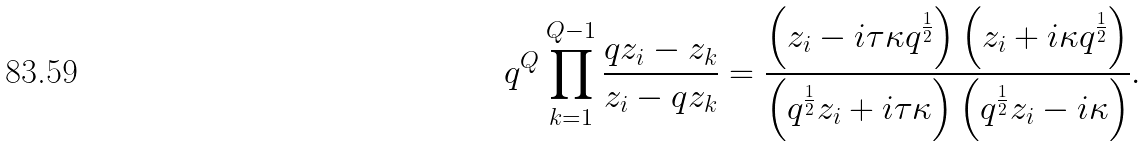Convert formula to latex. <formula><loc_0><loc_0><loc_500><loc_500>q ^ { Q } \prod _ { k = 1 } ^ { Q - 1 } \frac { q z _ { i } - z _ { k } } { z _ { i } - q z _ { k } } = \frac { \left ( z _ { i } - i \tau \kappa q ^ { \frac { 1 } { 2 } } \right ) \left ( z _ { i } + i \kappa q ^ { \frac { 1 } { 2 } } \right ) } { \left ( q ^ { \frac { 1 } { 2 } } z _ { i } + i \tau \kappa \right ) \left ( q ^ { \frac { 1 } { 2 } } z _ { i } - i \kappa \right ) } .</formula> 